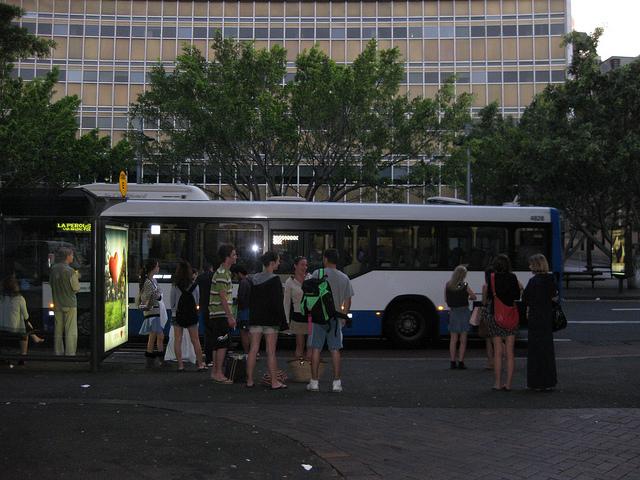How many people?
Quick response, please. 12. What colors are on the man's backpack?
Quick response, please. Black and green. Are some of these people desiring to make use of public transportation?
Concise answer only. Yes. 